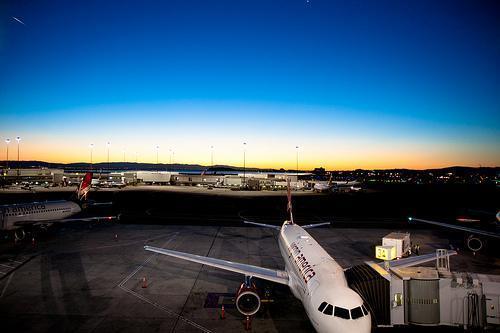How many airplane lights are red?
Give a very brief answer. 2. 